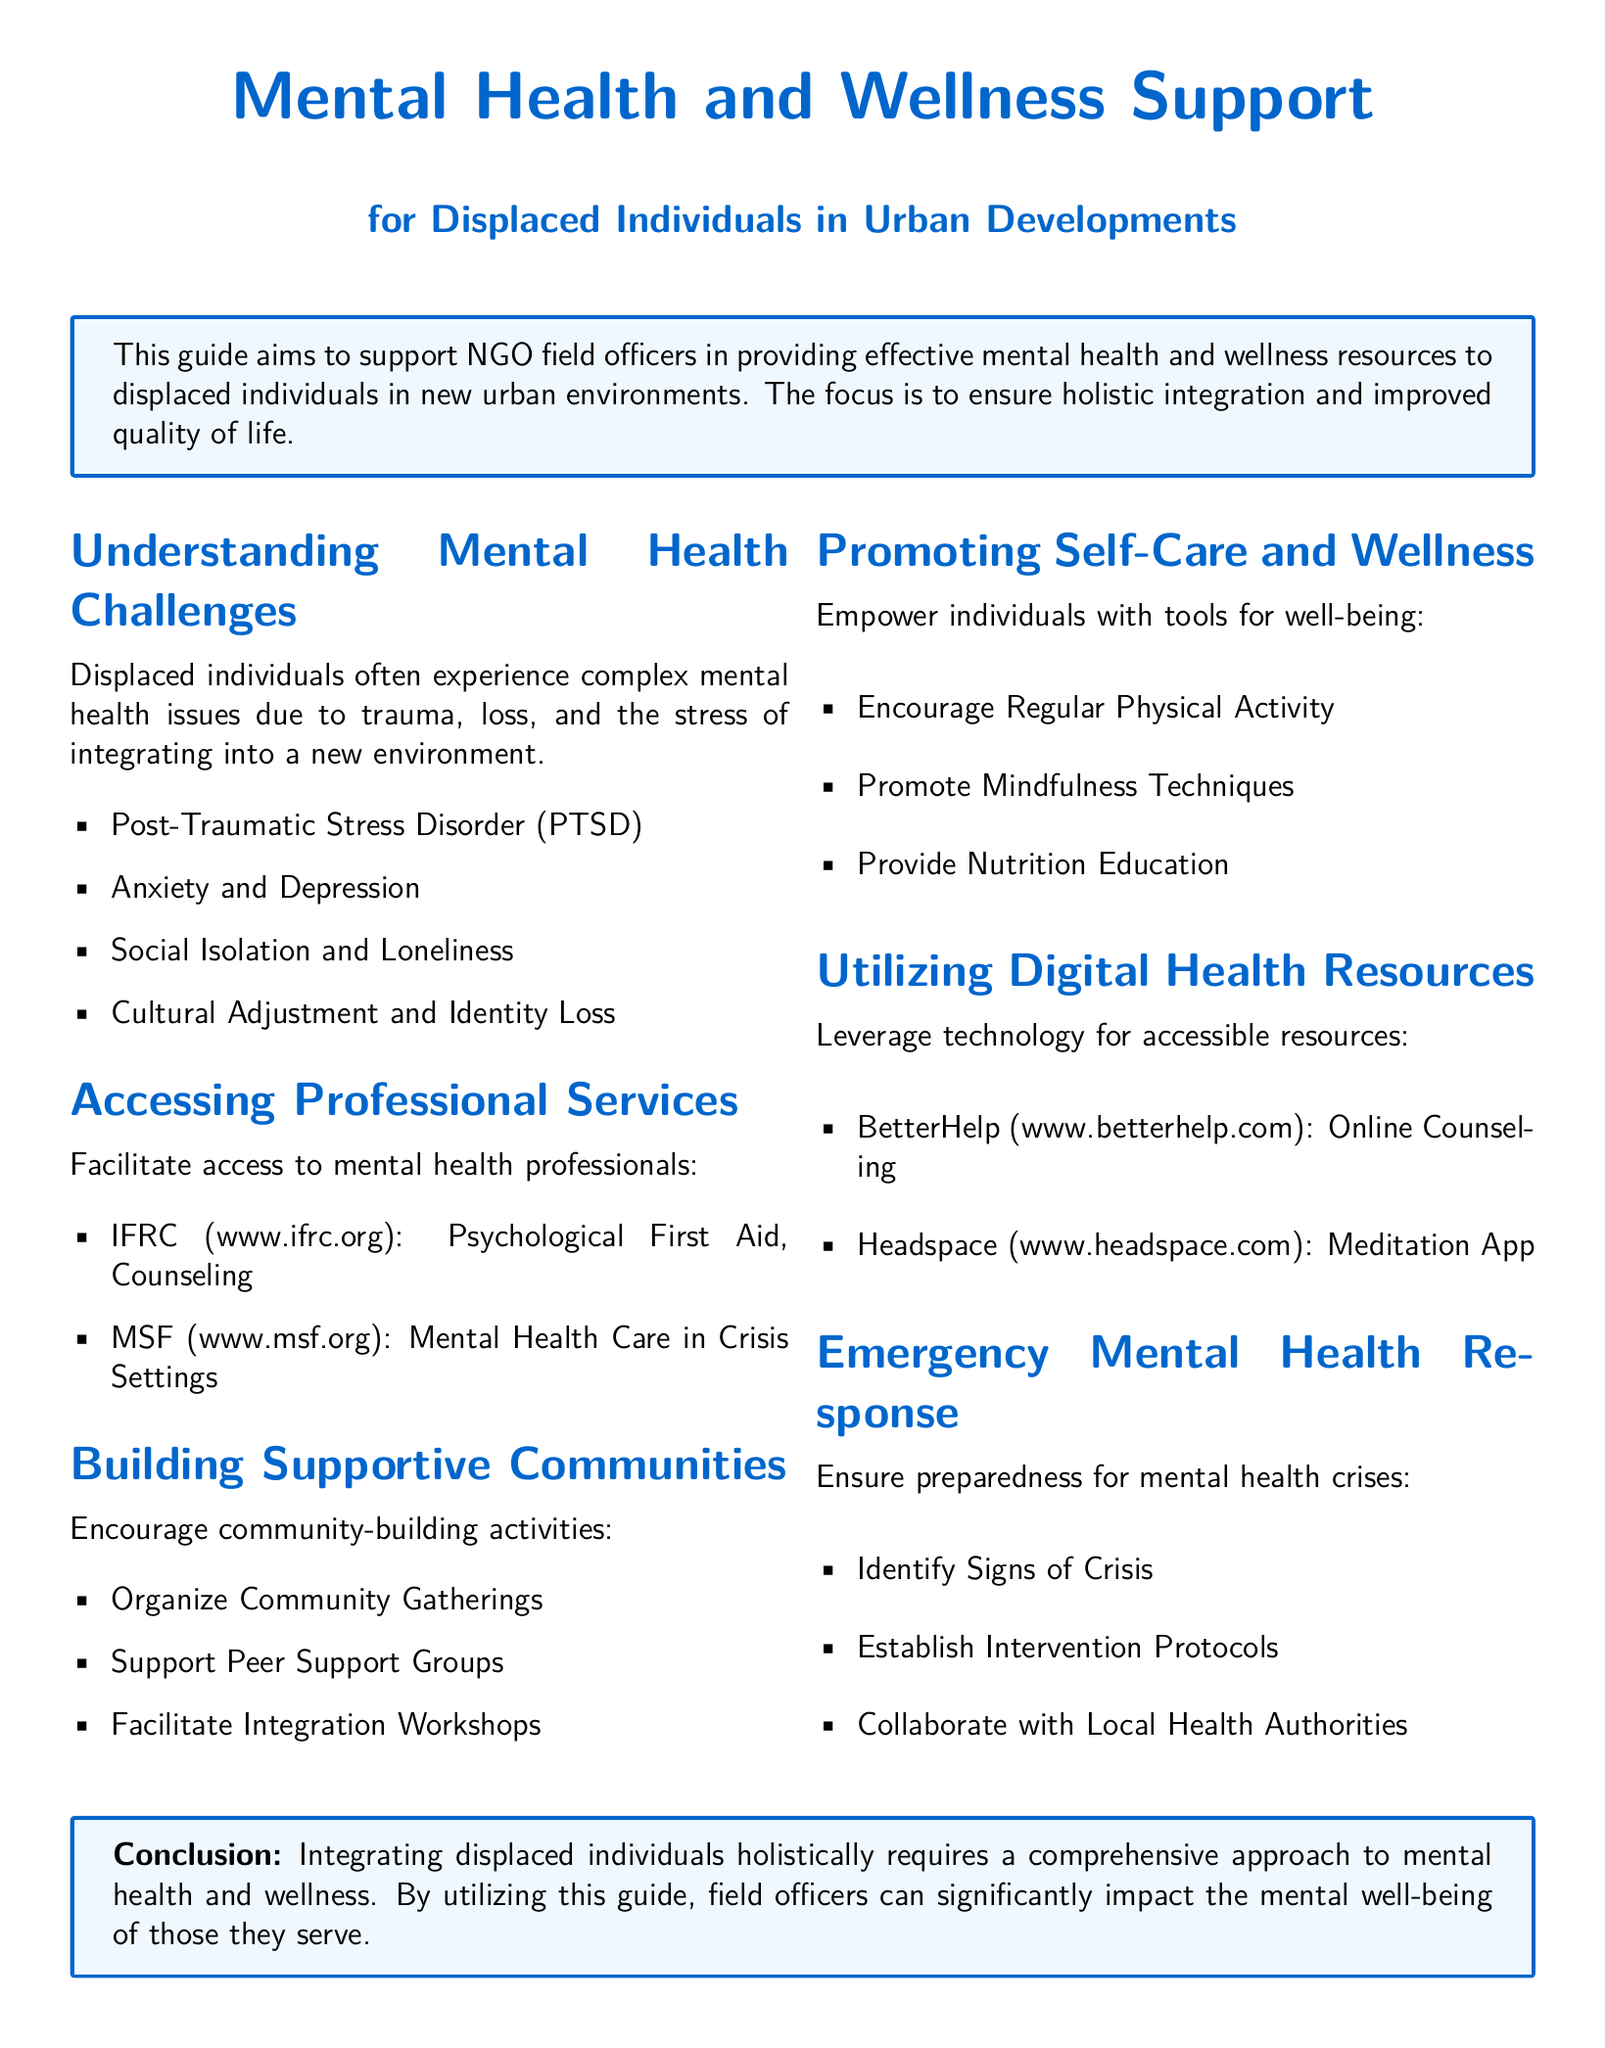What are common mental health issues for displaced individuals? The document lists several mental health challenges faced by displaced individuals, including PTSD, anxiety, depression, social isolation, and cultural adjustment.
Answer: PTSD, Anxiety, Depression, Social Isolation, Cultural Adjustment Which organizations provide mental health support? The guide mentions specific organizations that provide professional mental health services to displaced individuals.
Answer: IFRC, MSF What is one method to promote self-care? The document outlines various self-care strategies, one of which is engaging in regular physical activity.
Answer: Regular Physical Activity Name a digital health resource for counseling. The document provides examples of digital platforms that offer mental health support, one of which is BetterHelp.
Answer: BetterHelp What type of community activity is encouraged? The guide suggests actions to foster community, one of which is organizing community gatherings.
Answer: Community Gatherings What should be established for emergency mental health response? The document mentions the need for intervention protocols to be prepared for mental health crises.
Answer: Intervention Protocols What is the main focus of this guide? The guide states its primary purpose to assist NGO field officers in providing mental health resources to displaced individuals.
Answer: Support mental health and wellness resources How many sections are in the document? The document is organized into multiple sections focusing on different aspects of mental health support for displaced individuals.
Answer: Six Sections 